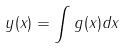<formula> <loc_0><loc_0><loc_500><loc_500>y ( x ) = \int g ( x ) d x</formula> 